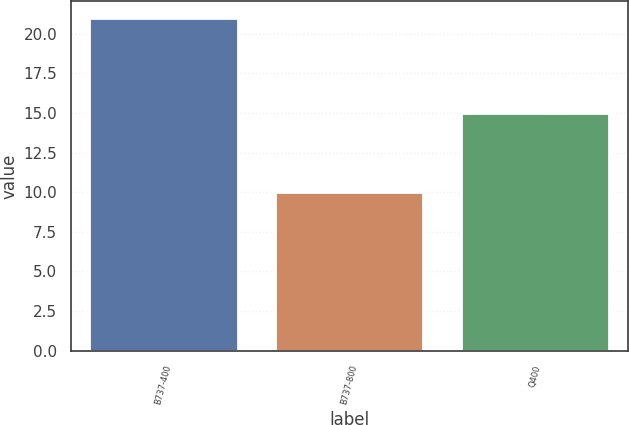Convert chart. <chart><loc_0><loc_0><loc_500><loc_500><bar_chart><fcel>B737-400<fcel>B737-800<fcel>Q400<nl><fcel>21<fcel>10<fcel>15<nl></chart> 